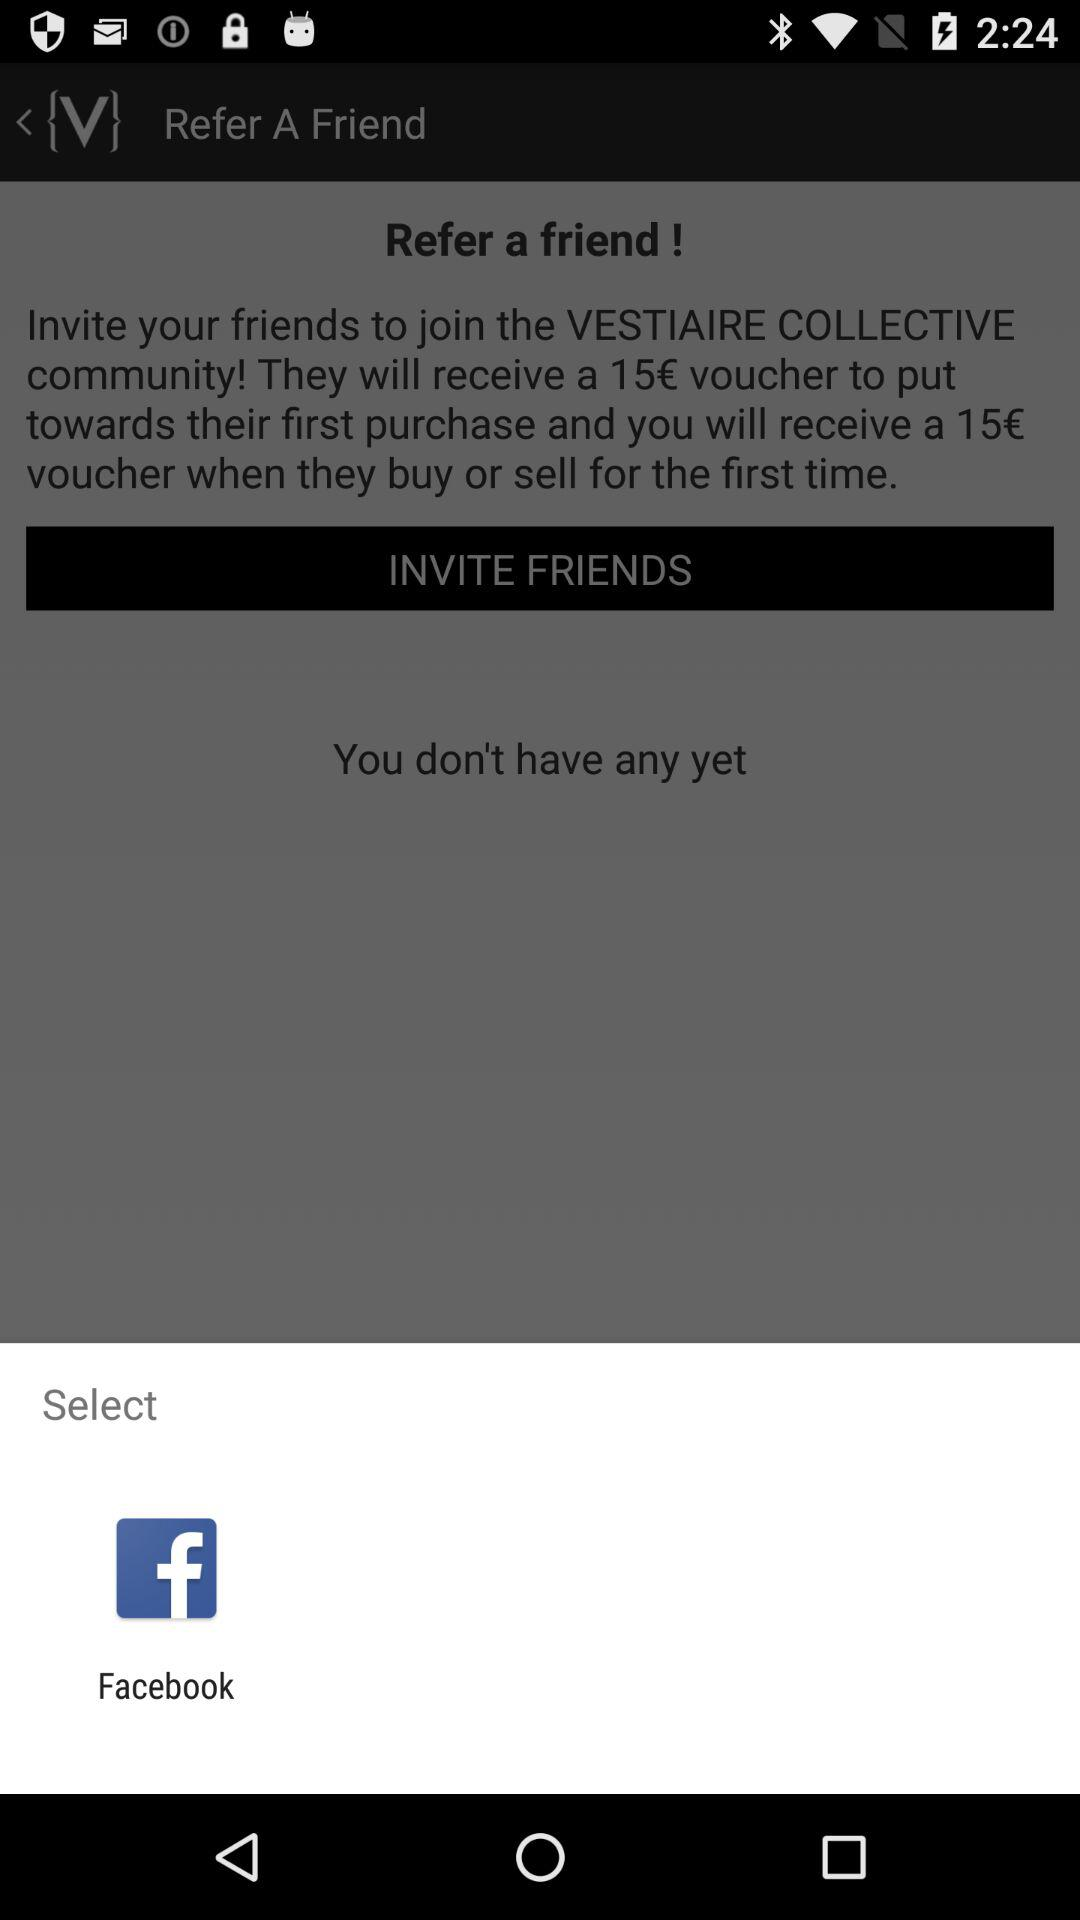How many friends have you referred?
Answer the question using a single word or phrase. 0 